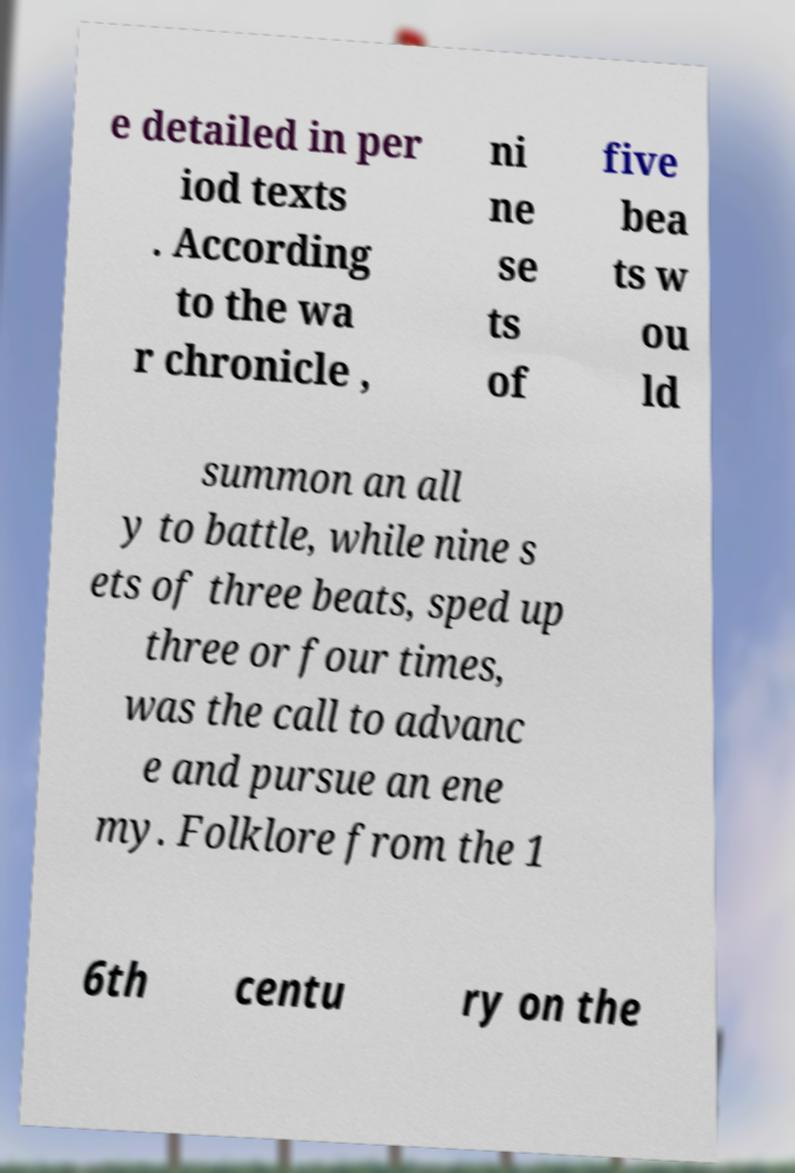Could you assist in decoding the text presented in this image and type it out clearly? e detailed in per iod texts . According to the wa r chronicle , ni ne se ts of five bea ts w ou ld summon an all y to battle, while nine s ets of three beats, sped up three or four times, was the call to advanc e and pursue an ene my. Folklore from the 1 6th centu ry on the 